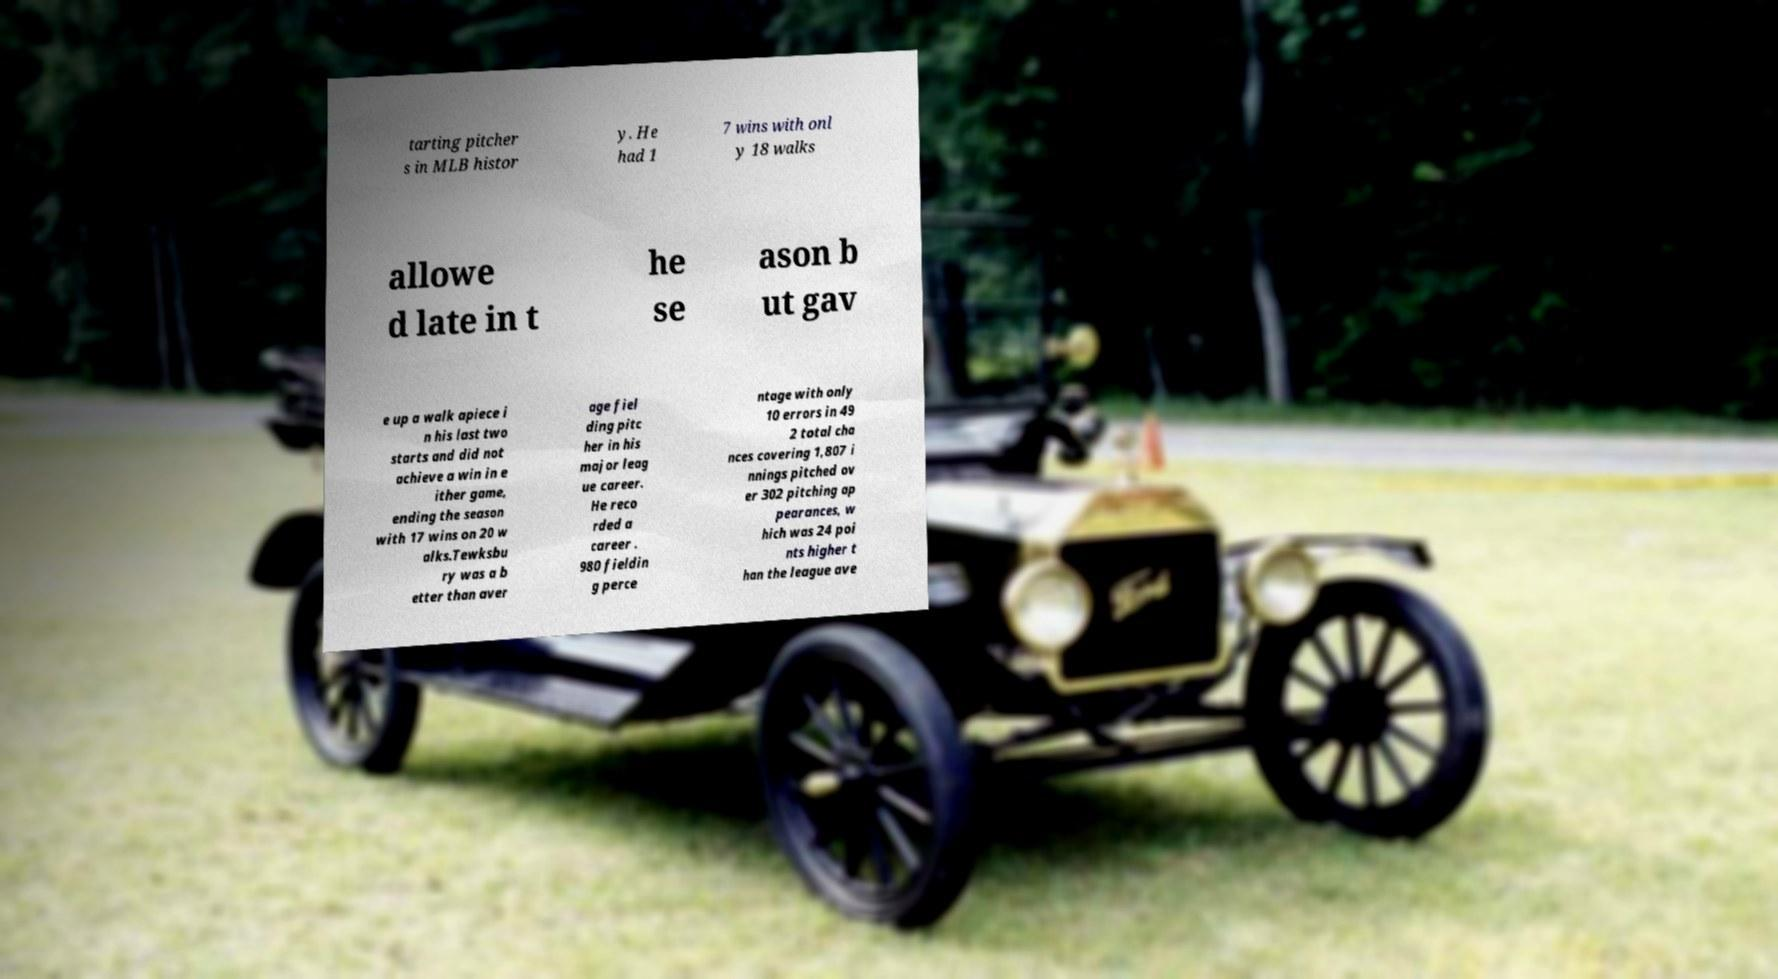Please read and relay the text visible in this image. What does it say? tarting pitcher s in MLB histor y. He had 1 7 wins with onl y 18 walks allowe d late in t he se ason b ut gav e up a walk apiece i n his last two starts and did not achieve a win in e ither game, ending the season with 17 wins on 20 w alks.Tewksbu ry was a b etter than aver age fiel ding pitc her in his major leag ue career. He reco rded a career . 980 fieldin g perce ntage with only 10 errors in 49 2 total cha nces covering 1,807 i nnings pitched ov er 302 pitching ap pearances, w hich was 24 poi nts higher t han the league ave 